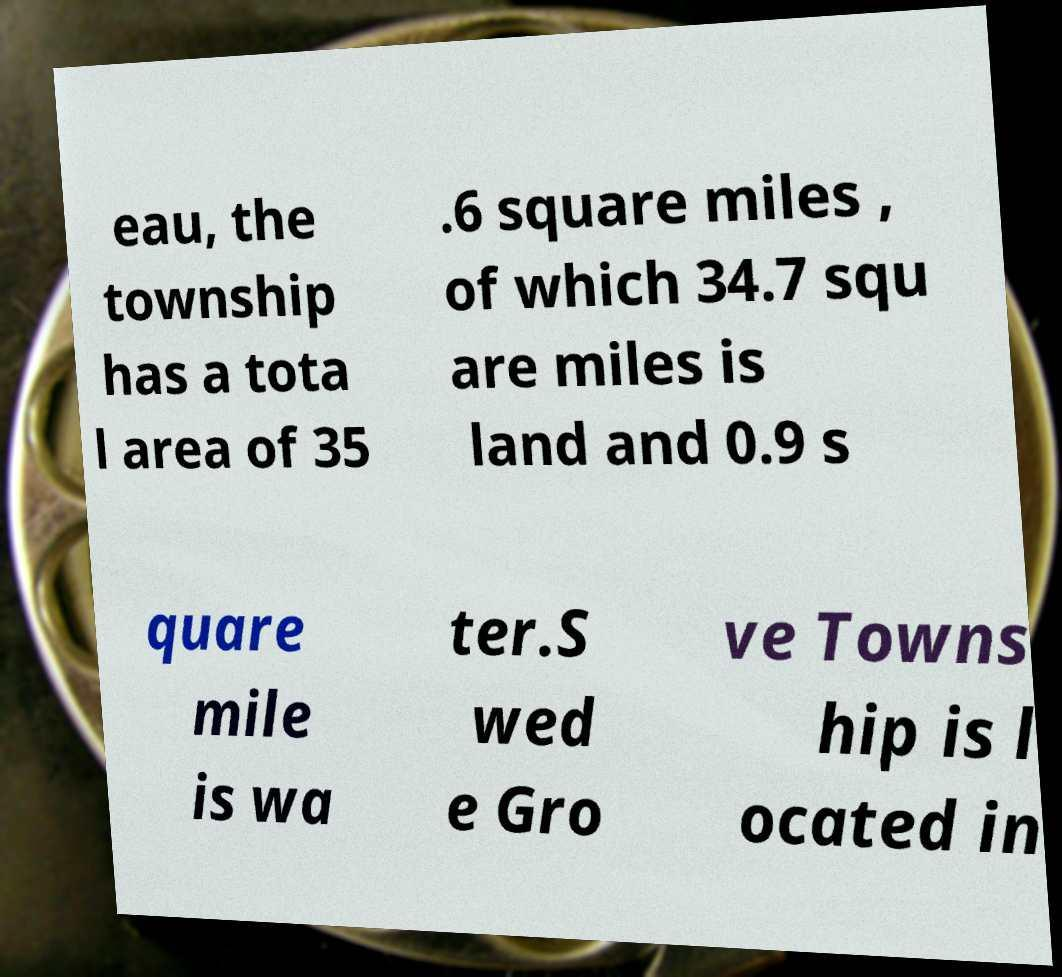Can you accurately transcribe the text from the provided image for me? eau, the township has a tota l area of 35 .6 square miles , of which 34.7 squ are miles is land and 0.9 s quare mile is wa ter.S wed e Gro ve Towns hip is l ocated in 